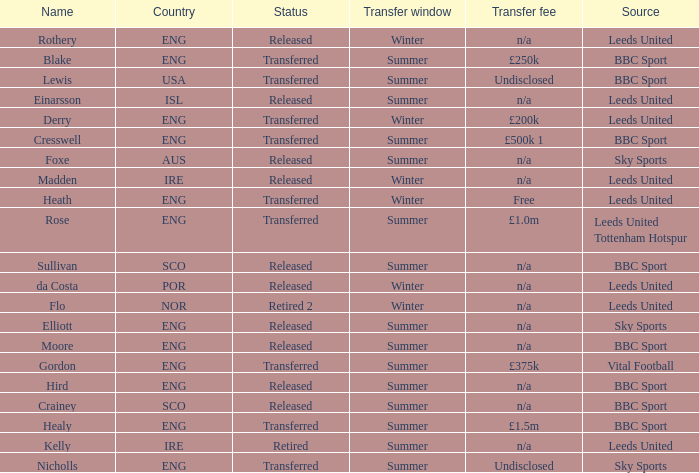What was the source for the person named Cresswell? BBC Sport. 